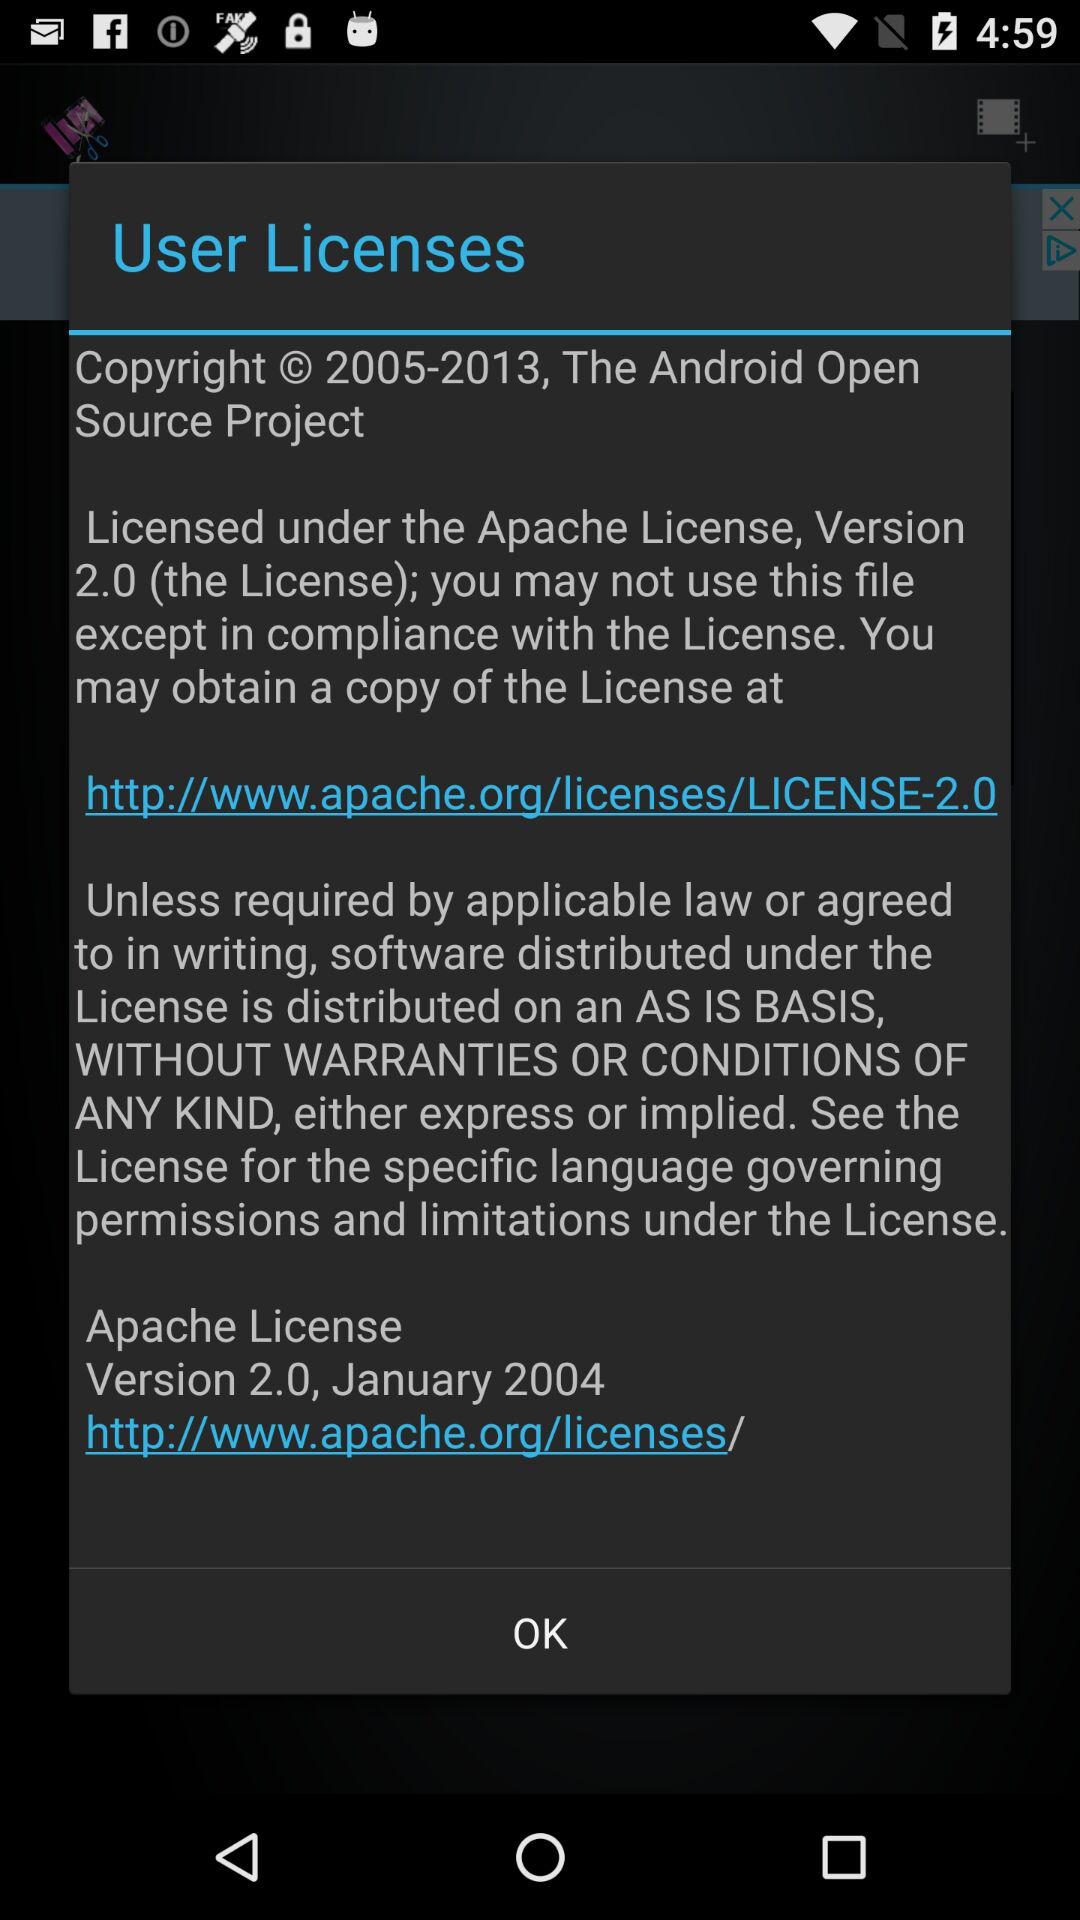When did user licensesgiven?
When the provided information is insufficient, respond with <no answer>. <no answer> 